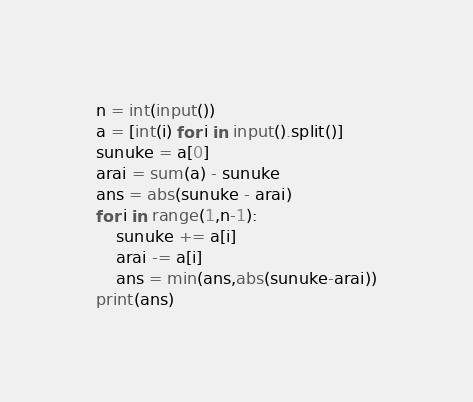Convert code to text. <code><loc_0><loc_0><loc_500><loc_500><_Python_>n = int(input())
a = [int(i) for i in input().split()]
sunuke = a[0]
arai = sum(a) - sunuke
ans = abs(sunuke - arai)
for i in range(1,n-1):
    sunuke += a[i]
    arai -= a[i]
    ans = min(ans,abs(sunuke-arai))
print(ans)</code> 